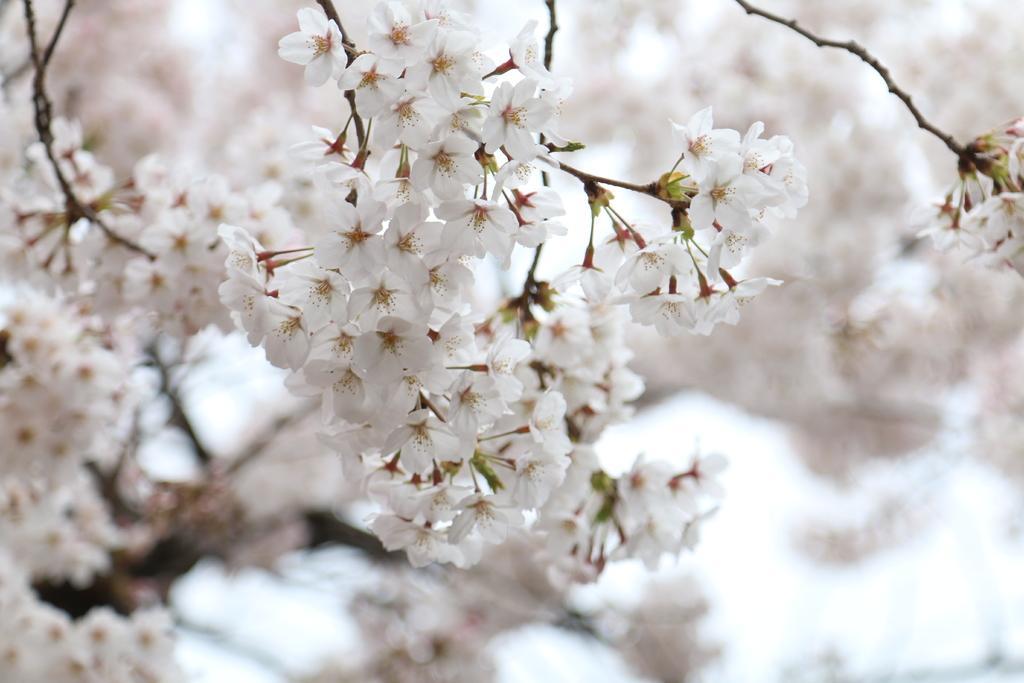Could you give a brief overview of what you see in this image? In the image we can see there are white flowers on the plant and behind there are flowers. Background of the image is blurred. 